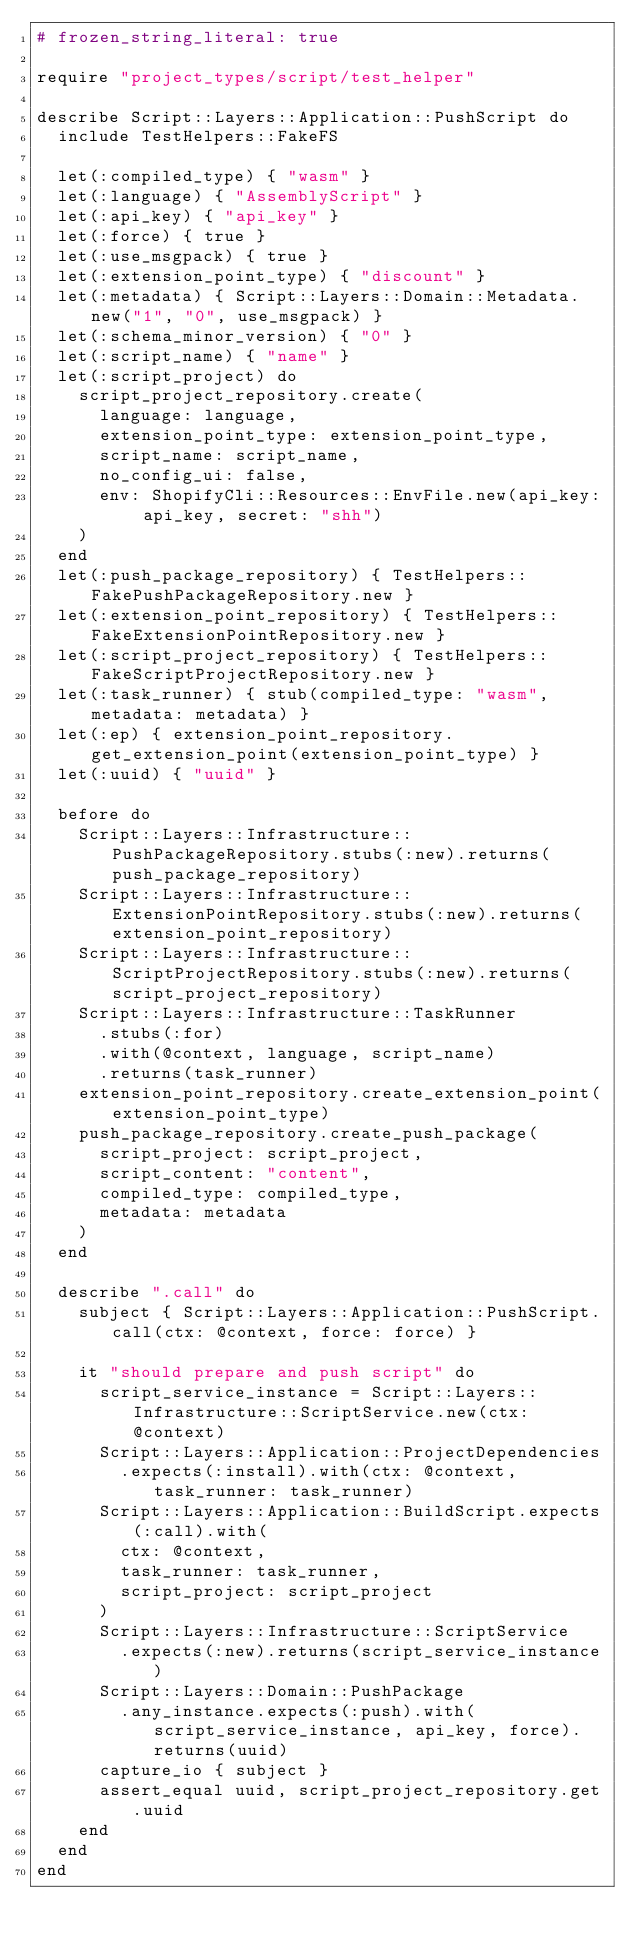<code> <loc_0><loc_0><loc_500><loc_500><_Ruby_># frozen_string_literal: true

require "project_types/script/test_helper"

describe Script::Layers::Application::PushScript do
  include TestHelpers::FakeFS

  let(:compiled_type) { "wasm" }
  let(:language) { "AssemblyScript" }
  let(:api_key) { "api_key" }
  let(:force) { true }
  let(:use_msgpack) { true }
  let(:extension_point_type) { "discount" }
  let(:metadata) { Script::Layers::Domain::Metadata.new("1", "0", use_msgpack) }
  let(:schema_minor_version) { "0" }
  let(:script_name) { "name" }
  let(:script_project) do
    script_project_repository.create(
      language: language,
      extension_point_type: extension_point_type,
      script_name: script_name,
      no_config_ui: false,
      env: ShopifyCli::Resources::EnvFile.new(api_key: api_key, secret: "shh")
    )
  end
  let(:push_package_repository) { TestHelpers::FakePushPackageRepository.new }
  let(:extension_point_repository) { TestHelpers::FakeExtensionPointRepository.new }
  let(:script_project_repository) { TestHelpers::FakeScriptProjectRepository.new }
  let(:task_runner) { stub(compiled_type: "wasm", metadata: metadata) }
  let(:ep) { extension_point_repository.get_extension_point(extension_point_type) }
  let(:uuid) { "uuid" }

  before do
    Script::Layers::Infrastructure::PushPackageRepository.stubs(:new).returns(push_package_repository)
    Script::Layers::Infrastructure::ExtensionPointRepository.stubs(:new).returns(extension_point_repository)
    Script::Layers::Infrastructure::ScriptProjectRepository.stubs(:new).returns(script_project_repository)
    Script::Layers::Infrastructure::TaskRunner
      .stubs(:for)
      .with(@context, language, script_name)
      .returns(task_runner)
    extension_point_repository.create_extension_point(extension_point_type)
    push_package_repository.create_push_package(
      script_project: script_project,
      script_content: "content",
      compiled_type: compiled_type,
      metadata: metadata
    )
  end

  describe ".call" do
    subject { Script::Layers::Application::PushScript.call(ctx: @context, force: force) }

    it "should prepare and push script" do
      script_service_instance = Script::Layers::Infrastructure::ScriptService.new(ctx: @context)
      Script::Layers::Application::ProjectDependencies
        .expects(:install).with(ctx: @context, task_runner: task_runner)
      Script::Layers::Application::BuildScript.expects(:call).with(
        ctx: @context,
        task_runner: task_runner,
        script_project: script_project
      )
      Script::Layers::Infrastructure::ScriptService
        .expects(:new).returns(script_service_instance)
      Script::Layers::Domain::PushPackage
        .any_instance.expects(:push).with(script_service_instance, api_key, force).returns(uuid)
      capture_io { subject }
      assert_equal uuid, script_project_repository.get.uuid
    end
  end
end
</code> 